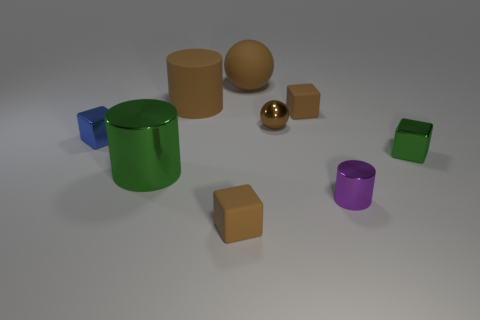The green shiny thing on the left side of the tiny brown block behind the purple object is what shape?
Provide a short and direct response. Cylinder. There is a brown object that is the same shape as the small purple thing; what material is it?
Ensure brevity in your answer.  Rubber. There is a sphere that is the same size as the green block; what is its color?
Keep it short and to the point. Brown. Are there an equal number of large metallic objects that are left of the large metallic cylinder and large brown things?
Keep it short and to the point. No. There is a matte cube that is in front of the small brown matte block behind the blue metal block; what color is it?
Provide a short and direct response. Brown. There is a green object on the left side of the brown block that is in front of the purple metallic cylinder; how big is it?
Make the answer very short. Large. There is a cylinder that is the same color as the large ball; what size is it?
Provide a short and direct response. Large. How many other objects are there of the same size as the brown metallic sphere?
Keep it short and to the point. 5. There is a small matte cube that is behind the ball that is in front of the brown matte object behind the large matte cylinder; what is its color?
Offer a terse response. Brown. What number of other things are there of the same shape as the blue metallic object?
Your answer should be compact. 3. 